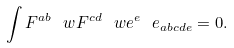<formula> <loc_0><loc_0><loc_500><loc_500>\int F ^ { a b } \ w F ^ { c d } \ w e ^ { e } \ e _ { a b c d e } = 0 .</formula> 